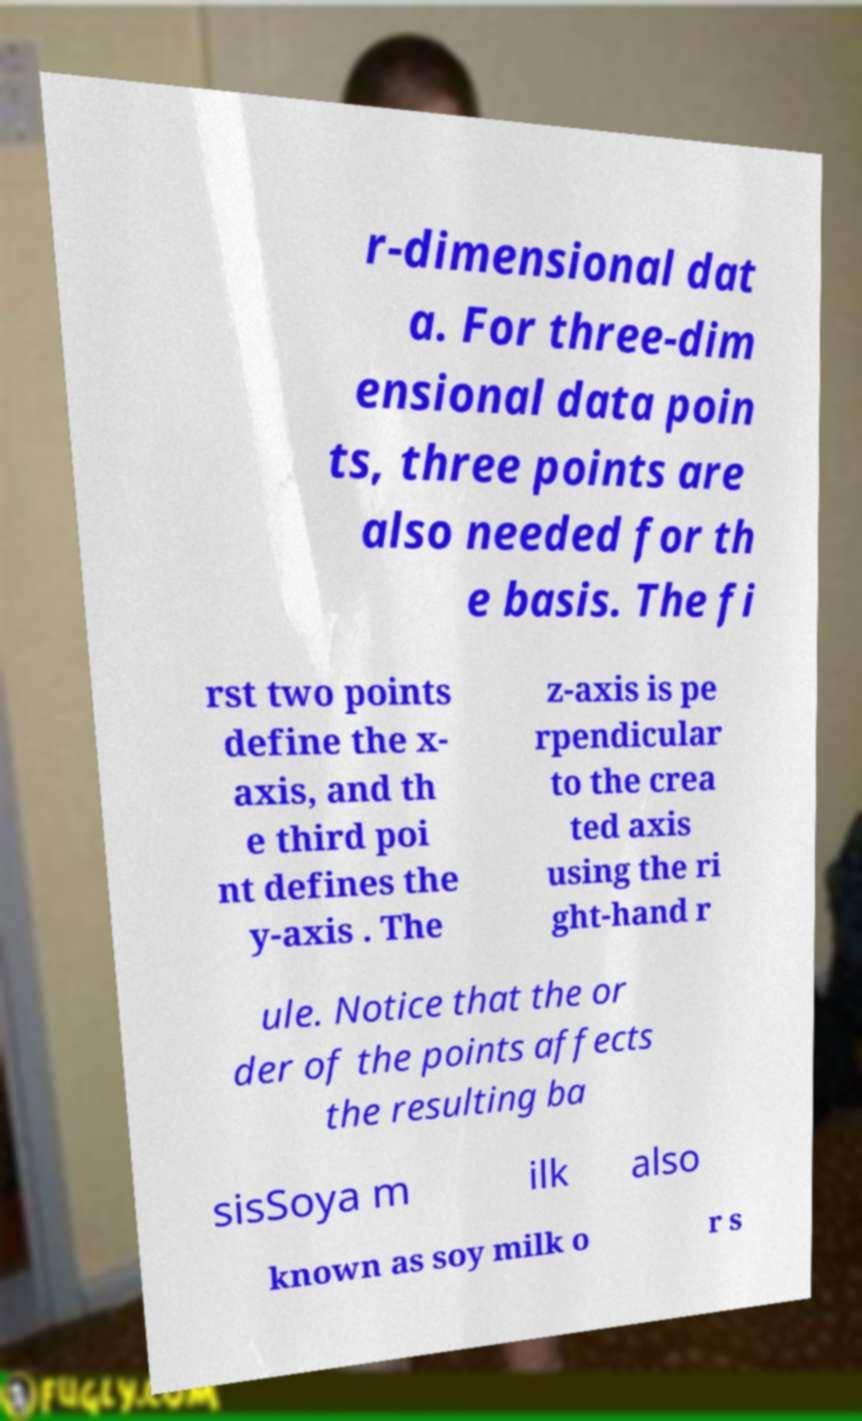Can you read and provide the text displayed in the image?This photo seems to have some interesting text. Can you extract and type it out for me? r-dimensional dat a. For three-dim ensional data poin ts, three points are also needed for th e basis. The fi rst two points define the x- axis, and th e third poi nt defines the y-axis . The z-axis is pe rpendicular to the crea ted axis using the ri ght-hand r ule. Notice that the or der of the points affects the resulting ba sisSoya m ilk also known as soy milk o r s 